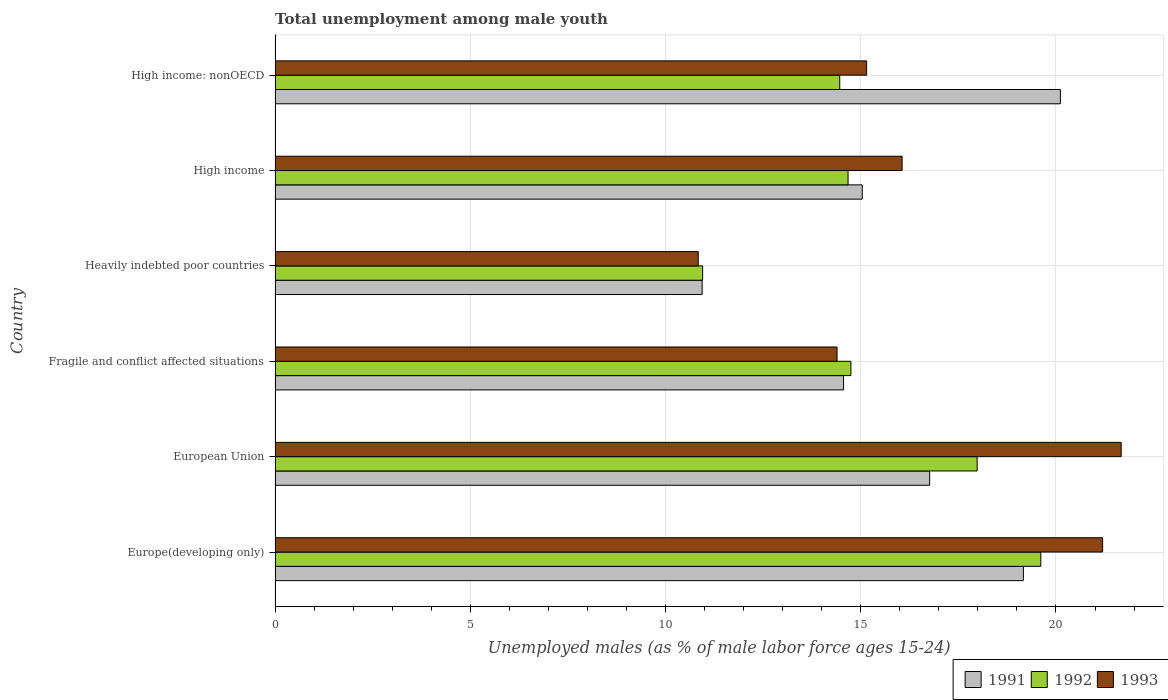Are the number of bars on each tick of the Y-axis equal?
Your answer should be compact. Yes. How many bars are there on the 3rd tick from the top?
Your answer should be very brief. 3. How many bars are there on the 2nd tick from the bottom?
Your answer should be very brief. 3. What is the label of the 5th group of bars from the top?
Make the answer very short. European Union. What is the percentage of unemployed males in in 1991 in High income: nonOECD?
Make the answer very short. 20.11. Across all countries, what is the maximum percentage of unemployed males in in 1992?
Your response must be concise. 19.61. Across all countries, what is the minimum percentage of unemployed males in in 1992?
Provide a succinct answer. 10.95. In which country was the percentage of unemployed males in in 1992 maximum?
Give a very brief answer. Europe(developing only). In which country was the percentage of unemployed males in in 1992 minimum?
Your response must be concise. Heavily indebted poor countries. What is the total percentage of unemployed males in in 1991 in the graph?
Your response must be concise. 96.58. What is the difference between the percentage of unemployed males in in 1992 in High income and that in High income: nonOECD?
Provide a succinct answer. 0.21. What is the difference between the percentage of unemployed males in in 1992 in Heavily indebted poor countries and the percentage of unemployed males in in 1991 in High income: nonOECD?
Ensure brevity in your answer.  -9.16. What is the average percentage of unemployed males in in 1993 per country?
Ensure brevity in your answer.  16.55. What is the difference between the percentage of unemployed males in in 1991 and percentage of unemployed males in in 1992 in European Union?
Keep it short and to the point. -1.22. In how many countries, is the percentage of unemployed males in in 1993 greater than 18 %?
Offer a terse response. 2. What is the ratio of the percentage of unemployed males in in 1993 in European Union to that in Fragile and conflict affected situations?
Your response must be concise. 1.51. What is the difference between the highest and the second highest percentage of unemployed males in in 1991?
Provide a short and direct response. 0.95. What is the difference between the highest and the lowest percentage of unemployed males in in 1993?
Offer a terse response. 10.83. Is the sum of the percentage of unemployed males in in 1992 in Europe(developing only) and Heavily indebted poor countries greater than the maximum percentage of unemployed males in in 1993 across all countries?
Provide a short and direct response. Yes. What does the 1st bar from the top in Fragile and conflict affected situations represents?
Your response must be concise. 1993. What does the 3rd bar from the bottom in High income: nonOECD represents?
Make the answer very short. 1993. Is it the case that in every country, the sum of the percentage of unemployed males in in 1992 and percentage of unemployed males in in 1993 is greater than the percentage of unemployed males in in 1991?
Your answer should be very brief. Yes. How many bars are there?
Your response must be concise. 18. Where does the legend appear in the graph?
Your answer should be compact. Bottom right. How many legend labels are there?
Give a very brief answer. 3. What is the title of the graph?
Make the answer very short. Total unemployment among male youth. Does "1976" appear as one of the legend labels in the graph?
Provide a short and direct response. No. What is the label or title of the X-axis?
Offer a very short reply. Unemployed males (as % of male labor force ages 15-24). What is the label or title of the Y-axis?
Offer a very short reply. Country. What is the Unemployed males (as % of male labor force ages 15-24) in 1991 in Europe(developing only)?
Give a very brief answer. 19.16. What is the Unemployed males (as % of male labor force ages 15-24) in 1992 in Europe(developing only)?
Your answer should be compact. 19.61. What is the Unemployed males (as % of male labor force ages 15-24) in 1993 in Europe(developing only)?
Your answer should be very brief. 21.19. What is the Unemployed males (as % of male labor force ages 15-24) of 1991 in European Union?
Give a very brief answer. 16.76. What is the Unemployed males (as % of male labor force ages 15-24) in 1992 in European Union?
Provide a succinct answer. 17.98. What is the Unemployed males (as % of male labor force ages 15-24) in 1993 in European Union?
Your answer should be very brief. 21.67. What is the Unemployed males (as % of male labor force ages 15-24) in 1991 in Fragile and conflict affected situations?
Ensure brevity in your answer.  14.56. What is the Unemployed males (as % of male labor force ages 15-24) in 1992 in Fragile and conflict affected situations?
Ensure brevity in your answer.  14.75. What is the Unemployed males (as % of male labor force ages 15-24) of 1993 in Fragile and conflict affected situations?
Give a very brief answer. 14.39. What is the Unemployed males (as % of male labor force ages 15-24) in 1991 in Heavily indebted poor countries?
Offer a very short reply. 10.94. What is the Unemployed males (as % of male labor force ages 15-24) of 1992 in Heavily indebted poor countries?
Give a very brief answer. 10.95. What is the Unemployed males (as % of male labor force ages 15-24) of 1993 in Heavily indebted poor countries?
Make the answer very short. 10.84. What is the Unemployed males (as % of male labor force ages 15-24) in 1991 in High income?
Provide a succinct answer. 15.04. What is the Unemployed males (as % of male labor force ages 15-24) in 1992 in High income?
Make the answer very short. 14.67. What is the Unemployed males (as % of male labor force ages 15-24) in 1993 in High income?
Provide a short and direct response. 16.06. What is the Unemployed males (as % of male labor force ages 15-24) in 1991 in High income: nonOECD?
Provide a succinct answer. 20.11. What is the Unemployed males (as % of male labor force ages 15-24) of 1992 in High income: nonOECD?
Your answer should be compact. 14.46. What is the Unemployed males (as % of male labor force ages 15-24) in 1993 in High income: nonOECD?
Provide a succinct answer. 15.15. Across all countries, what is the maximum Unemployed males (as % of male labor force ages 15-24) in 1991?
Your answer should be compact. 20.11. Across all countries, what is the maximum Unemployed males (as % of male labor force ages 15-24) of 1992?
Your answer should be compact. 19.61. Across all countries, what is the maximum Unemployed males (as % of male labor force ages 15-24) in 1993?
Make the answer very short. 21.67. Across all countries, what is the minimum Unemployed males (as % of male labor force ages 15-24) in 1991?
Offer a very short reply. 10.94. Across all countries, what is the minimum Unemployed males (as % of male labor force ages 15-24) in 1992?
Keep it short and to the point. 10.95. Across all countries, what is the minimum Unemployed males (as % of male labor force ages 15-24) of 1993?
Your answer should be compact. 10.84. What is the total Unemployed males (as % of male labor force ages 15-24) in 1991 in the graph?
Make the answer very short. 96.58. What is the total Unemployed males (as % of male labor force ages 15-24) in 1992 in the graph?
Provide a short and direct response. 92.43. What is the total Unemployed males (as % of male labor force ages 15-24) of 1993 in the graph?
Offer a very short reply. 99.3. What is the difference between the Unemployed males (as % of male labor force ages 15-24) in 1991 in Europe(developing only) and that in European Union?
Offer a very short reply. 2.4. What is the difference between the Unemployed males (as % of male labor force ages 15-24) of 1992 in Europe(developing only) and that in European Union?
Your answer should be very brief. 1.63. What is the difference between the Unemployed males (as % of male labor force ages 15-24) in 1993 in Europe(developing only) and that in European Union?
Provide a short and direct response. -0.48. What is the difference between the Unemployed males (as % of male labor force ages 15-24) in 1991 in Europe(developing only) and that in Fragile and conflict affected situations?
Offer a very short reply. 4.61. What is the difference between the Unemployed males (as % of male labor force ages 15-24) of 1992 in Europe(developing only) and that in Fragile and conflict affected situations?
Offer a terse response. 4.86. What is the difference between the Unemployed males (as % of male labor force ages 15-24) in 1993 in Europe(developing only) and that in Fragile and conflict affected situations?
Keep it short and to the point. 6.8. What is the difference between the Unemployed males (as % of male labor force ages 15-24) in 1991 in Europe(developing only) and that in Heavily indebted poor countries?
Your answer should be very brief. 8.23. What is the difference between the Unemployed males (as % of male labor force ages 15-24) of 1992 in Europe(developing only) and that in Heavily indebted poor countries?
Keep it short and to the point. 8.66. What is the difference between the Unemployed males (as % of male labor force ages 15-24) of 1993 in Europe(developing only) and that in Heavily indebted poor countries?
Give a very brief answer. 10.36. What is the difference between the Unemployed males (as % of male labor force ages 15-24) of 1991 in Europe(developing only) and that in High income?
Offer a very short reply. 4.13. What is the difference between the Unemployed males (as % of male labor force ages 15-24) of 1992 in Europe(developing only) and that in High income?
Keep it short and to the point. 4.94. What is the difference between the Unemployed males (as % of male labor force ages 15-24) in 1993 in Europe(developing only) and that in High income?
Provide a short and direct response. 5.14. What is the difference between the Unemployed males (as % of male labor force ages 15-24) in 1991 in Europe(developing only) and that in High income: nonOECD?
Make the answer very short. -0.95. What is the difference between the Unemployed males (as % of male labor force ages 15-24) in 1992 in Europe(developing only) and that in High income: nonOECD?
Offer a very short reply. 5.15. What is the difference between the Unemployed males (as % of male labor force ages 15-24) of 1993 in Europe(developing only) and that in High income: nonOECD?
Keep it short and to the point. 6.04. What is the difference between the Unemployed males (as % of male labor force ages 15-24) in 1991 in European Union and that in Fragile and conflict affected situations?
Offer a very short reply. 2.2. What is the difference between the Unemployed males (as % of male labor force ages 15-24) of 1992 in European Union and that in Fragile and conflict affected situations?
Your answer should be very brief. 3.23. What is the difference between the Unemployed males (as % of male labor force ages 15-24) of 1993 in European Union and that in Fragile and conflict affected situations?
Provide a succinct answer. 7.28. What is the difference between the Unemployed males (as % of male labor force ages 15-24) in 1991 in European Union and that in Heavily indebted poor countries?
Give a very brief answer. 5.83. What is the difference between the Unemployed males (as % of male labor force ages 15-24) in 1992 in European Union and that in Heavily indebted poor countries?
Offer a very short reply. 7.03. What is the difference between the Unemployed males (as % of male labor force ages 15-24) in 1993 in European Union and that in Heavily indebted poor countries?
Give a very brief answer. 10.83. What is the difference between the Unemployed males (as % of male labor force ages 15-24) of 1991 in European Union and that in High income?
Your response must be concise. 1.73. What is the difference between the Unemployed males (as % of male labor force ages 15-24) in 1992 in European Union and that in High income?
Your answer should be compact. 3.31. What is the difference between the Unemployed males (as % of male labor force ages 15-24) in 1993 in European Union and that in High income?
Keep it short and to the point. 5.61. What is the difference between the Unemployed males (as % of male labor force ages 15-24) in 1991 in European Union and that in High income: nonOECD?
Make the answer very short. -3.35. What is the difference between the Unemployed males (as % of male labor force ages 15-24) in 1992 in European Union and that in High income: nonOECD?
Provide a succinct answer. 3.52. What is the difference between the Unemployed males (as % of male labor force ages 15-24) of 1993 in European Union and that in High income: nonOECD?
Your response must be concise. 6.52. What is the difference between the Unemployed males (as % of male labor force ages 15-24) of 1991 in Fragile and conflict affected situations and that in Heavily indebted poor countries?
Make the answer very short. 3.62. What is the difference between the Unemployed males (as % of male labor force ages 15-24) in 1992 in Fragile and conflict affected situations and that in Heavily indebted poor countries?
Offer a terse response. 3.8. What is the difference between the Unemployed males (as % of male labor force ages 15-24) in 1993 in Fragile and conflict affected situations and that in Heavily indebted poor countries?
Offer a very short reply. 3.56. What is the difference between the Unemployed males (as % of male labor force ages 15-24) in 1991 in Fragile and conflict affected situations and that in High income?
Make the answer very short. -0.48. What is the difference between the Unemployed males (as % of male labor force ages 15-24) of 1992 in Fragile and conflict affected situations and that in High income?
Your answer should be very brief. 0.07. What is the difference between the Unemployed males (as % of male labor force ages 15-24) of 1993 in Fragile and conflict affected situations and that in High income?
Keep it short and to the point. -1.67. What is the difference between the Unemployed males (as % of male labor force ages 15-24) in 1991 in Fragile and conflict affected situations and that in High income: nonOECD?
Keep it short and to the point. -5.55. What is the difference between the Unemployed males (as % of male labor force ages 15-24) in 1992 in Fragile and conflict affected situations and that in High income: nonOECD?
Offer a very short reply. 0.29. What is the difference between the Unemployed males (as % of male labor force ages 15-24) in 1993 in Fragile and conflict affected situations and that in High income: nonOECD?
Give a very brief answer. -0.76. What is the difference between the Unemployed males (as % of male labor force ages 15-24) in 1991 in Heavily indebted poor countries and that in High income?
Ensure brevity in your answer.  -4.1. What is the difference between the Unemployed males (as % of male labor force ages 15-24) in 1992 in Heavily indebted poor countries and that in High income?
Make the answer very short. -3.72. What is the difference between the Unemployed males (as % of male labor force ages 15-24) in 1993 in Heavily indebted poor countries and that in High income?
Give a very brief answer. -5.22. What is the difference between the Unemployed males (as % of male labor force ages 15-24) in 1991 in Heavily indebted poor countries and that in High income: nonOECD?
Make the answer very short. -9.18. What is the difference between the Unemployed males (as % of male labor force ages 15-24) in 1992 in Heavily indebted poor countries and that in High income: nonOECD?
Offer a very short reply. -3.51. What is the difference between the Unemployed males (as % of male labor force ages 15-24) in 1993 in Heavily indebted poor countries and that in High income: nonOECD?
Make the answer very short. -4.31. What is the difference between the Unemployed males (as % of male labor force ages 15-24) in 1991 in High income and that in High income: nonOECD?
Your answer should be compact. -5.07. What is the difference between the Unemployed males (as % of male labor force ages 15-24) of 1992 in High income and that in High income: nonOECD?
Offer a very short reply. 0.21. What is the difference between the Unemployed males (as % of male labor force ages 15-24) of 1993 in High income and that in High income: nonOECD?
Provide a succinct answer. 0.91. What is the difference between the Unemployed males (as % of male labor force ages 15-24) in 1991 in Europe(developing only) and the Unemployed males (as % of male labor force ages 15-24) in 1992 in European Union?
Make the answer very short. 1.18. What is the difference between the Unemployed males (as % of male labor force ages 15-24) of 1991 in Europe(developing only) and the Unemployed males (as % of male labor force ages 15-24) of 1993 in European Union?
Offer a very short reply. -2.5. What is the difference between the Unemployed males (as % of male labor force ages 15-24) of 1992 in Europe(developing only) and the Unemployed males (as % of male labor force ages 15-24) of 1993 in European Union?
Your answer should be compact. -2.06. What is the difference between the Unemployed males (as % of male labor force ages 15-24) of 1991 in Europe(developing only) and the Unemployed males (as % of male labor force ages 15-24) of 1992 in Fragile and conflict affected situations?
Provide a short and direct response. 4.42. What is the difference between the Unemployed males (as % of male labor force ages 15-24) of 1991 in Europe(developing only) and the Unemployed males (as % of male labor force ages 15-24) of 1993 in Fragile and conflict affected situations?
Your answer should be very brief. 4.77. What is the difference between the Unemployed males (as % of male labor force ages 15-24) of 1992 in Europe(developing only) and the Unemployed males (as % of male labor force ages 15-24) of 1993 in Fragile and conflict affected situations?
Provide a short and direct response. 5.22. What is the difference between the Unemployed males (as % of male labor force ages 15-24) of 1991 in Europe(developing only) and the Unemployed males (as % of male labor force ages 15-24) of 1992 in Heavily indebted poor countries?
Make the answer very short. 8.21. What is the difference between the Unemployed males (as % of male labor force ages 15-24) in 1991 in Europe(developing only) and the Unemployed males (as % of male labor force ages 15-24) in 1993 in Heavily indebted poor countries?
Ensure brevity in your answer.  8.33. What is the difference between the Unemployed males (as % of male labor force ages 15-24) in 1992 in Europe(developing only) and the Unemployed males (as % of male labor force ages 15-24) in 1993 in Heavily indebted poor countries?
Offer a very short reply. 8.77. What is the difference between the Unemployed males (as % of male labor force ages 15-24) of 1991 in Europe(developing only) and the Unemployed males (as % of male labor force ages 15-24) of 1992 in High income?
Offer a terse response. 4.49. What is the difference between the Unemployed males (as % of male labor force ages 15-24) in 1991 in Europe(developing only) and the Unemployed males (as % of male labor force ages 15-24) in 1993 in High income?
Provide a short and direct response. 3.11. What is the difference between the Unemployed males (as % of male labor force ages 15-24) of 1992 in Europe(developing only) and the Unemployed males (as % of male labor force ages 15-24) of 1993 in High income?
Your answer should be compact. 3.55. What is the difference between the Unemployed males (as % of male labor force ages 15-24) in 1991 in Europe(developing only) and the Unemployed males (as % of male labor force ages 15-24) in 1992 in High income: nonOECD?
Your response must be concise. 4.7. What is the difference between the Unemployed males (as % of male labor force ages 15-24) in 1991 in Europe(developing only) and the Unemployed males (as % of male labor force ages 15-24) in 1993 in High income: nonOECD?
Your answer should be compact. 4.01. What is the difference between the Unemployed males (as % of male labor force ages 15-24) of 1992 in Europe(developing only) and the Unemployed males (as % of male labor force ages 15-24) of 1993 in High income: nonOECD?
Your response must be concise. 4.46. What is the difference between the Unemployed males (as % of male labor force ages 15-24) of 1991 in European Union and the Unemployed males (as % of male labor force ages 15-24) of 1992 in Fragile and conflict affected situations?
Offer a very short reply. 2.02. What is the difference between the Unemployed males (as % of male labor force ages 15-24) in 1991 in European Union and the Unemployed males (as % of male labor force ages 15-24) in 1993 in Fragile and conflict affected situations?
Your answer should be compact. 2.37. What is the difference between the Unemployed males (as % of male labor force ages 15-24) of 1992 in European Union and the Unemployed males (as % of male labor force ages 15-24) of 1993 in Fragile and conflict affected situations?
Ensure brevity in your answer.  3.59. What is the difference between the Unemployed males (as % of male labor force ages 15-24) of 1991 in European Union and the Unemployed males (as % of male labor force ages 15-24) of 1992 in Heavily indebted poor countries?
Your answer should be very brief. 5.81. What is the difference between the Unemployed males (as % of male labor force ages 15-24) of 1991 in European Union and the Unemployed males (as % of male labor force ages 15-24) of 1993 in Heavily indebted poor countries?
Give a very brief answer. 5.93. What is the difference between the Unemployed males (as % of male labor force ages 15-24) of 1992 in European Union and the Unemployed males (as % of male labor force ages 15-24) of 1993 in Heavily indebted poor countries?
Make the answer very short. 7.14. What is the difference between the Unemployed males (as % of male labor force ages 15-24) of 1991 in European Union and the Unemployed males (as % of male labor force ages 15-24) of 1992 in High income?
Offer a very short reply. 2.09. What is the difference between the Unemployed males (as % of male labor force ages 15-24) of 1991 in European Union and the Unemployed males (as % of male labor force ages 15-24) of 1993 in High income?
Your answer should be very brief. 0.71. What is the difference between the Unemployed males (as % of male labor force ages 15-24) in 1992 in European Union and the Unemployed males (as % of male labor force ages 15-24) in 1993 in High income?
Your answer should be very brief. 1.92. What is the difference between the Unemployed males (as % of male labor force ages 15-24) in 1991 in European Union and the Unemployed males (as % of male labor force ages 15-24) in 1992 in High income: nonOECD?
Give a very brief answer. 2.3. What is the difference between the Unemployed males (as % of male labor force ages 15-24) in 1991 in European Union and the Unemployed males (as % of male labor force ages 15-24) in 1993 in High income: nonOECD?
Give a very brief answer. 1.61. What is the difference between the Unemployed males (as % of male labor force ages 15-24) of 1992 in European Union and the Unemployed males (as % of male labor force ages 15-24) of 1993 in High income: nonOECD?
Your answer should be very brief. 2.83. What is the difference between the Unemployed males (as % of male labor force ages 15-24) in 1991 in Fragile and conflict affected situations and the Unemployed males (as % of male labor force ages 15-24) in 1992 in Heavily indebted poor countries?
Your answer should be very brief. 3.61. What is the difference between the Unemployed males (as % of male labor force ages 15-24) in 1991 in Fragile and conflict affected situations and the Unemployed males (as % of male labor force ages 15-24) in 1993 in Heavily indebted poor countries?
Your answer should be very brief. 3.72. What is the difference between the Unemployed males (as % of male labor force ages 15-24) in 1992 in Fragile and conflict affected situations and the Unemployed males (as % of male labor force ages 15-24) in 1993 in Heavily indebted poor countries?
Provide a succinct answer. 3.91. What is the difference between the Unemployed males (as % of male labor force ages 15-24) of 1991 in Fragile and conflict affected situations and the Unemployed males (as % of male labor force ages 15-24) of 1992 in High income?
Give a very brief answer. -0.12. What is the difference between the Unemployed males (as % of male labor force ages 15-24) in 1991 in Fragile and conflict affected situations and the Unemployed males (as % of male labor force ages 15-24) in 1993 in High income?
Offer a very short reply. -1.5. What is the difference between the Unemployed males (as % of male labor force ages 15-24) of 1992 in Fragile and conflict affected situations and the Unemployed males (as % of male labor force ages 15-24) of 1993 in High income?
Provide a succinct answer. -1.31. What is the difference between the Unemployed males (as % of male labor force ages 15-24) in 1991 in Fragile and conflict affected situations and the Unemployed males (as % of male labor force ages 15-24) in 1992 in High income: nonOECD?
Offer a terse response. 0.1. What is the difference between the Unemployed males (as % of male labor force ages 15-24) of 1991 in Fragile and conflict affected situations and the Unemployed males (as % of male labor force ages 15-24) of 1993 in High income: nonOECD?
Keep it short and to the point. -0.59. What is the difference between the Unemployed males (as % of male labor force ages 15-24) in 1992 in Fragile and conflict affected situations and the Unemployed males (as % of male labor force ages 15-24) in 1993 in High income: nonOECD?
Give a very brief answer. -0.4. What is the difference between the Unemployed males (as % of male labor force ages 15-24) in 1991 in Heavily indebted poor countries and the Unemployed males (as % of male labor force ages 15-24) in 1992 in High income?
Make the answer very short. -3.74. What is the difference between the Unemployed males (as % of male labor force ages 15-24) in 1991 in Heavily indebted poor countries and the Unemployed males (as % of male labor force ages 15-24) in 1993 in High income?
Your answer should be very brief. -5.12. What is the difference between the Unemployed males (as % of male labor force ages 15-24) of 1992 in Heavily indebted poor countries and the Unemployed males (as % of male labor force ages 15-24) of 1993 in High income?
Your response must be concise. -5.11. What is the difference between the Unemployed males (as % of male labor force ages 15-24) of 1991 in Heavily indebted poor countries and the Unemployed males (as % of male labor force ages 15-24) of 1992 in High income: nonOECD?
Ensure brevity in your answer.  -3.52. What is the difference between the Unemployed males (as % of male labor force ages 15-24) in 1991 in Heavily indebted poor countries and the Unemployed males (as % of male labor force ages 15-24) in 1993 in High income: nonOECD?
Your answer should be compact. -4.21. What is the difference between the Unemployed males (as % of male labor force ages 15-24) of 1992 in Heavily indebted poor countries and the Unemployed males (as % of male labor force ages 15-24) of 1993 in High income: nonOECD?
Keep it short and to the point. -4.2. What is the difference between the Unemployed males (as % of male labor force ages 15-24) in 1991 in High income and the Unemployed males (as % of male labor force ages 15-24) in 1992 in High income: nonOECD?
Give a very brief answer. 0.58. What is the difference between the Unemployed males (as % of male labor force ages 15-24) in 1991 in High income and the Unemployed males (as % of male labor force ages 15-24) in 1993 in High income: nonOECD?
Provide a short and direct response. -0.11. What is the difference between the Unemployed males (as % of male labor force ages 15-24) of 1992 in High income and the Unemployed males (as % of male labor force ages 15-24) of 1993 in High income: nonOECD?
Ensure brevity in your answer.  -0.48. What is the average Unemployed males (as % of male labor force ages 15-24) in 1991 per country?
Ensure brevity in your answer.  16.1. What is the average Unemployed males (as % of male labor force ages 15-24) of 1992 per country?
Offer a terse response. 15.4. What is the average Unemployed males (as % of male labor force ages 15-24) in 1993 per country?
Provide a succinct answer. 16.55. What is the difference between the Unemployed males (as % of male labor force ages 15-24) in 1991 and Unemployed males (as % of male labor force ages 15-24) in 1992 in Europe(developing only)?
Provide a succinct answer. -0.45. What is the difference between the Unemployed males (as % of male labor force ages 15-24) of 1991 and Unemployed males (as % of male labor force ages 15-24) of 1993 in Europe(developing only)?
Keep it short and to the point. -2.03. What is the difference between the Unemployed males (as % of male labor force ages 15-24) of 1992 and Unemployed males (as % of male labor force ages 15-24) of 1993 in Europe(developing only)?
Keep it short and to the point. -1.58. What is the difference between the Unemployed males (as % of male labor force ages 15-24) in 1991 and Unemployed males (as % of male labor force ages 15-24) in 1992 in European Union?
Make the answer very short. -1.22. What is the difference between the Unemployed males (as % of male labor force ages 15-24) in 1991 and Unemployed males (as % of male labor force ages 15-24) in 1993 in European Union?
Keep it short and to the point. -4.91. What is the difference between the Unemployed males (as % of male labor force ages 15-24) of 1992 and Unemployed males (as % of male labor force ages 15-24) of 1993 in European Union?
Make the answer very short. -3.69. What is the difference between the Unemployed males (as % of male labor force ages 15-24) in 1991 and Unemployed males (as % of male labor force ages 15-24) in 1992 in Fragile and conflict affected situations?
Provide a short and direct response. -0.19. What is the difference between the Unemployed males (as % of male labor force ages 15-24) of 1991 and Unemployed males (as % of male labor force ages 15-24) of 1993 in Fragile and conflict affected situations?
Provide a short and direct response. 0.17. What is the difference between the Unemployed males (as % of male labor force ages 15-24) in 1992 and Unemployed males (as % of male labor force ages 15-24) in 1993 in Fragile and conflict affected situations?
Ensure brevity in your answer.  0.36. What is the difference between the Unemployed males (as % of male labor force ages 15-24) of 1991 and Unemployed males (as % of male labor force ages 15-24) of 1992 in Heavily indebted poor countries?
Keep it short and to the point. -0.01. What is the difference between the Unemployed males (as % of male labor force ages 15-24) in 1991 and Unemployed males (as % of male labor force ages 15-24) in 1993 in Heavily indebted poor countries?
Make the answer very short. 0.1. What is the difference between the Unemployed males (as % of male labor force ages 15-24) of 1992 and Unemployed males (as % of male labor force ages 15-24) of 1993 in Heavily indebted poor countries?
Provide a succinct answer. 0.11. What is the difference between the Unemployed males (as % of male labor force ages 15-24) in 1991 and Unemployed males (as % of male labor force ages 15-24) in 1992 in High income?
Give a very brief answer. 0.36. What is the difference between the Unemployed males (as % of male labor force ages 15-24) of 1991 and Unemployed males (as % of male labor force ages 15-24) of 1993 in High income?
Offer a very short reply. -1.02. What is the difference between the Unemployed males (as % of male labor force ages 15-24) of 1992 and Unemployed males (as % of male labor force ages 15-24) of 1993 in High income?
Your answer should be very brief. -1.38. What is the difference between the Unemployed males (as % of male labor force ages 15-24) of 1991 and Unemployed males (as % of male labor force ages 15-24) of 1992 in High income: nonOECD?
Make the answer very short. 5.65. What is the difference between the Unemployed males (as % of male labor force ages 15-24) in 1991 and Unemployed males (as % of male labor force ages 15-24) in 1993 in High income: nonOECD?
Ensure brevity in your answer.  4.96. What is the difference between the Unemployed males (as % of male labor force ages 15-24) in 1992 and Unemployed males (as % of male labor force ages 15-24) in 1993 in High income: nonOECD?
Your answer should be very brief. -0.69. What is the ratio of the Unemployed males (as % of male labor force ages 15-24) in 1991 in Europe(developing only) to that in European Union?
Give a very brief answer. 1.14. What is the ratio of the Unemployed males (as % of male labor force ages 15-24) in 1992 in Europe(developing only) to that in European Union?
Offer a terse response. 1.09. What is the ratio of the Unemployed males (as % of male labor force ages 15-24) in 1993 in Europe(developing only) to that in European Union?
Provide a short and direct response. 0.98. What is the ratio of the Unemployed males (as % of male labor force ages 15-24) of 1991 in Europe(developing only) to that in Fragile and conflict affected situations?
Ensure brevity in your answer.  1.32. What is the ratio of the Unemployed males (as % of male labor force ages 15-24) of 1992 in Europe(developing only) to that in Fragile and conflict affected situations?
Your response must be concise. 1.33. What is the ratio of the Unemployed males (as % of male labor force ages 15-24) of 1993 in Europe(developing only) to that in Fragile and conflict affected situations?
Keep it short and to the point. 1.47. What is the ratio of the Unemployed males (as % of male labor force ages 15-24) in 1991 in Europe(developing only) to that in Heavily indebted poor countries?
Keep it short and to the point. 1.75. What is the ratio of the Unemployed males (as % of male labor force ages 15-24) of 1992 in Europe(developing only) to that in Heavily indebted poor countries?
Offer a very short reply. 1.79. What is the ratio of the Unemployed males (as % of male labor force ages 15-24) of 1993 in Europe(developing only) to that in Heavily indebted poor countries?
Your response must be concise. 1.96. What is the ratio of the Unemployed males (as % of male labor force ages 15-24) of 1991 in Europe(developing only) to that in High income?
Keep it short and to the point. 1.27. What is the ratio of the Unemployed males (as % of male labor force ages 15-24) of 1992 in Europe(developing only) to that in High income?
Offer a very short reply. 1.34. What is the ratio of the Unemployed males (as % of male labor force ages 15-24) of 1993 in Europe(developing only) to that in High income?
Your answer should be compact. 1.32. What is the ratio of the Unemployed males (as % of male labor force ages 15-24) in 1991 in Europe(developing only) to that in High income: nonOECD?
Offer a terse response. 0.95. What is the ratio of the Unemployed males (as % of male labor force ages 15-24) of 1992 in Europe(developing only) to that in High income: nonOECD?
Your response must be concise. 1.36. What is the ratio of the Unemployed males (as % of male labor force ages 15-24) of 1993 in Europe(developing only) to that in High income: nonOECD?
Provide a succinct answer. 1.4. What is the ratio of the Unemployed males (as % of male labor force ages 15-24) of 1991 in European Union to that in Fragile and conflict affected situations?
Offer a very short reply. 1.15. What is the ratio of the Unemployed males (as % of male labor force ages 15-24) in 1992 in European Union to that in Fragile and conflict affected situations?
Offer a very short reply. 1.22. What is the ratio of the Unemployed males (as % of male labor force ages 15-24) of 1993 in European Union to that in Fragile and conflict affected situations?
Offer a very short reply. 1.51. What is the ratio of the Unemployed males (as % of male labor force ages 15-24) in 1991 in European Union to that in Heavily indebted poor countries?
Provide a short and direct response. 1.53. What is the ratio of the Unemployed males (as % of male labor force ages 15-24) of 1992 in European Union to that in Heavily indebted poor countries?
Provide a succinct answer. 1.64. What is the ratio of the Unemployed males (as % of male labor force ages 15-24) of 1993 in European Union to that in Heavily indebted poor countries?
Keep it short and to the point. 2. What is the ratio of the Unemployed males (as % of male labor force ages 15-24) in 1991 in European Union to that in High income?
Offer a very short reply. 1.11. What is the ratio of the Unemployed males (as % of male labor force ages 15-24) in 1992 in European Union to that in High income?
Your answer should be compact. 1.23. What is the ratio of the Unemployed males (as % of male labor force ages 15-24) of 1993 in European Union to that in High income?
Give a very brief answer. 1.35. What is the ratio of the Unemployed males (as % of male labor force ages 15-24) in 1991 in European Union to that in High income: nonOECD?
Provide a short and direct response. 0.83. What is the ratio of the Unemployed males (as % of male labor force ages 15-24) of 1992 in European Union to that in High income: nonOECD?
Your response must be concise. 1.24. What is the ratio of the Unemployed males (as % of male labor force ages 15-24) of 1993 in European Union to that in High income: nonOECD?
Keep it short and to the point. 1.43. What is the ratio of the Unemployed males (as % of male labor force ages 15-24) in 1991 in Fragile and conflict affected situations to that in Heavily indebted poor countries?
Offer a very short reply. 1.33. What is the ratio of the Unemployed males (as % of male labor force ages 15-24) in 1992 in Fragile and conflict affected situations to that in Heavily indebted poor countries?
Keep it short and to the point. 1.35. What is the ratio of the Unemployed males (as % of male labor force ages 15-24) in 1993 in Fragile and conflict affected situations to that in Heavily indebted poor countries?
Ensure brevity in your answer.  1.33. What is the ratio of the Unemployed males (as % of male labor force ages 15-24) of 1991 in Fragile and conflict affected situations to that in High income?
Your response must be concise. 0.97. What is the ratio of the Unemployed males (as % of male labor force ages 15-24) in 1992 in Fragile and conflict affected situations to that in High income?
Keep it short and to the point. 1. What is the ratio of the Unemployed males (as % of male labor force ages 15-24) of 1993 in Fragile and conflict affected situations to that in High income?
Give a very brief answer. 0.9. What is the ratio of the Unemployed males (as % of male labor force ages 15-24) in 1991 in Fragile and conflict affected situations to that in High income: nonOECD?
Offer a terse response. 0.72. What is the ratio of the Unemployed males (as % of male labor force ages 15-24) of 1992 in Fragile and conflict affected situations to that in High income: nonOECD?
Offer a very short reply. 1.02. What is the ratio of the Unemployed males (as % of male labor force ages 15-24) in 1993 in Fragile and conflict affected situations to that in High income: nonOECD?
Offer a terse response. 0.95. What is the ratio of the Unemployed males (as % of male labor force ages 15-24) of 1991 in Heavily indebted poor countries to that in High income?
Your answer should be compact. 0.73. What is the ratio of the Unemployed males (as % of male labor force ages 15-24) of 1992 in Heavily indebted poor countries to that in High income?
Provide a short and direct response. 0.75. What is the ratio of the Unemployed males (as % of male labor force ages 15-24) of 1993 in Heavily indebted poor countries to that in High income?
Give a very brief answer. 0.67. What is the ratio of the Unemployed males (as % of male labor force ages 15-24) in 1991 in Heavily indebted poor countries to that in High income: nonOECD?
Make the answer very short. 0.54. What is the ratio of the Unemployed males (as % of male labor force ages 15-24) in 1992 in Heavily indebted poor countries to that in High income: nonOECD?
Offer a very short reply. 0.76. What is the ratio of the Unemployed males (as % of male labor force ages 15-24) in 1993 in Heavily indebted poor countries to that in High income: nonOECD?
Your answer should be very brief. 0.72. What is the ratio of the Unemployed males (as % of male labor force ages 15-24) of 1991 in High income to that in High income: nonOECD?
Keep it short and to the point. 0.75. What is the ratio of the Unemployed males (as % of male labor force ages 15-24) in 1992 in High income to that in High income: nonOECD?
Provide a succinct answer. 1.01. What is the ratio of the Unemployed males (as % of male labor force ages 15-24) of 1993 in High income to that in High income: nonOECD?
Your answer should be very brief. 1.06. What is the difference between the highest and the second highest Unemployed males (as % of male labor force ages 15-24) of 1991?
Provide a short and direct response. 0.95. What is the difference between the highest and the second highest Unemployed males (as % of male labor force ages 15-24) in 1992?
Your answer should be very brief. 1.63. What is the difference between the highest and the second highest Unemployed males (as % of male labor force ages 15-24) of 1993?
Ensure brevity in your answer.  0.48. What is the difference between the highest and the lowest Unemployed males (as % of male labor force ages 15-24) in 1991?
Your answer should be very brief. 9.18. What is the difference between the highest and the lowest Unemployed males (as % of male labor force ages 15-24) of 1992?
Your response must be concise. 8.66. What is the difference between the highest and the lowest Unemployed males (as % of male labor force ages 15-24) of 1993?
Keep it short and to the point. 10.83. 